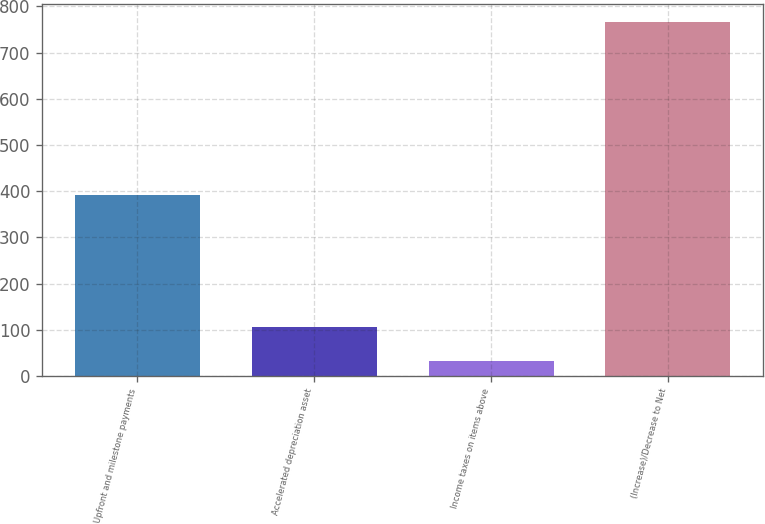Convert chart. <chart><loc_0><loc_0><loc_500><loc_500><bar_chart><fcel>Upfront and milestone payments<fcel>Accelerated depreciation asset<fcel>Income taxes on items above<fcel>(Increase)/Decrease to Net<nl><fcel>392<fcel>106.4<fcel>33<fcel>767<nl></chart> 